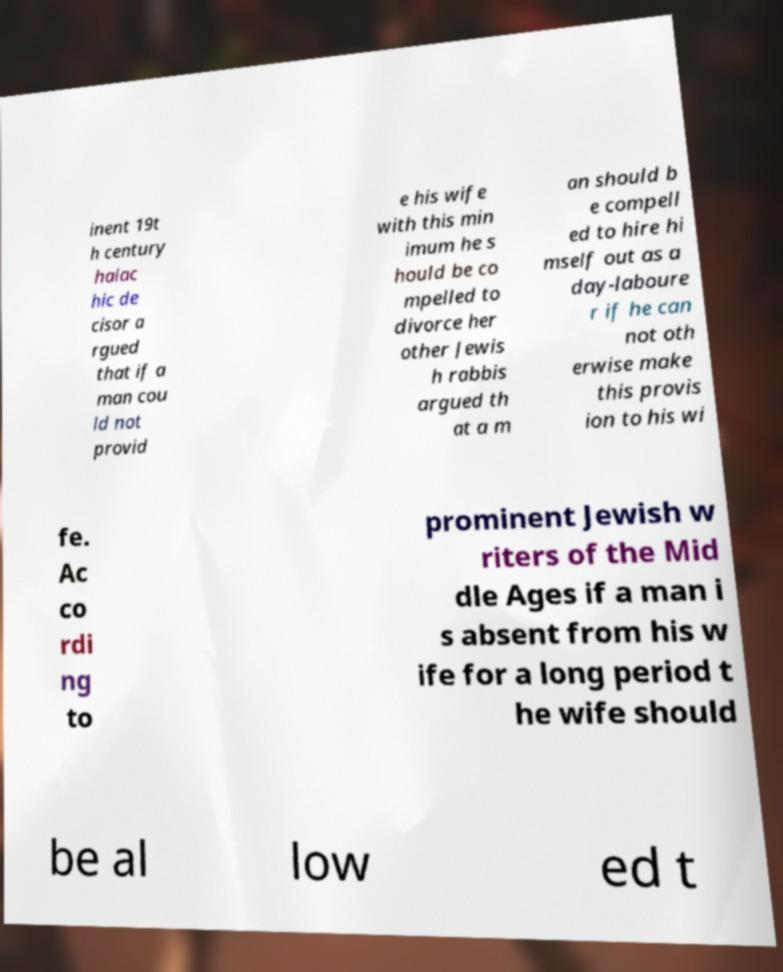I need the written content from this picture converted into text. Can you do that? inent 19t h century halac hic de cisor a rgued that if a man cou ld not provid e his wife with this min imum he s hould be co mpelled to divorce her other Jewis h rabbis argued th at a m an should b e compell ed to hire hi mself out as a day-laboure r if he can not oth erwise make this provis ion to his wi fe. Ac co rdi ng to prominent Jewish w riters of the Mid dle Ages if a man i s absent from his w ife for a long period t he wife should be al low ed t 